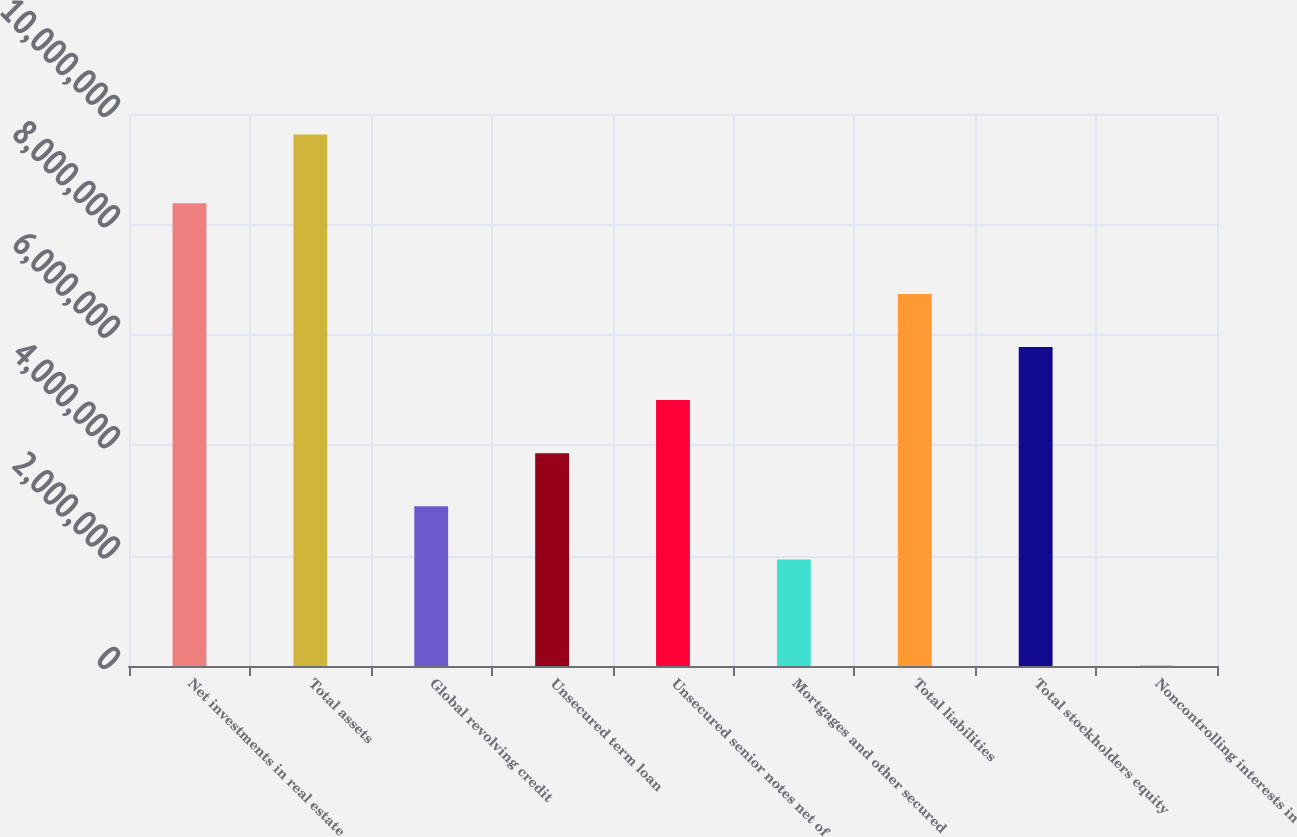<chart> <loc_0><loc_0><loc_500><loc_500><bar_chart><fcel>Net investments in real estate<fcel>Total assets<fcel>Global revolving credit<fcel>Unsecured term loan<fcel>Unsecured senior notes net of<fcel>Mortgages and other secured<fcel>Total liabilities<fcel>Total stockholders equity<fcel>Noncontrolling interests in<nl><fcel>8.38409e+06<fcel>9.62683e+06<fcel>2.89293e+06<fcel>3.85491e+06<fcel>4.8169e+06<fcel>1.93094e+06<fcel>6.74087e+06<fcel>5.77889e+06<fcel>6969<nl></chart> 